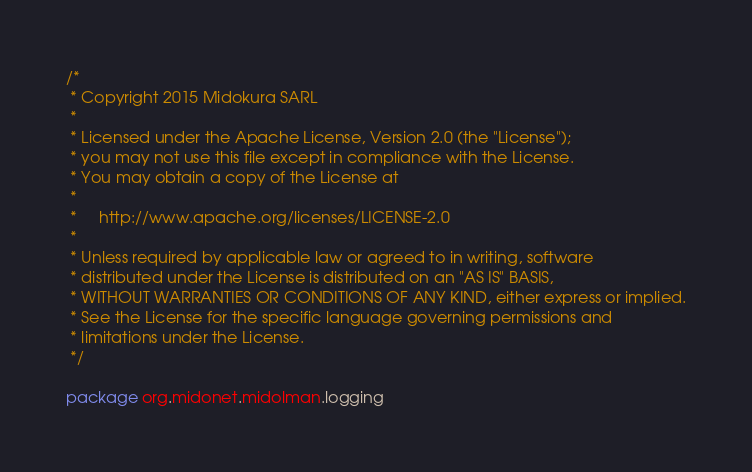<code> <loc_0><loc_0><loc_500><loc_500><_Scala_>/*
 * Copyright 2015 Midokura SARL
 *
 * Licensed under the Apache License, Version 2.0 (the "License");
 * you may not use this file except in compliance with the License.
 * You may obtain a copy of the License at
 *
 *     http://www.apache.org/licenses/LICENSE-2.0
 *
 * Unless required by applicable law or agreed to in writing, software
 * distributed under the License is distributed on an "AS IS" BASIS,
 * WITHOUT WARRANTIES OR CONDITIONS OF ANY KIND, either express or implied.
 * See the License for the specific language governing permissions and
 * limitations under the License.
 */

package org.midonet.midolman.logging
</code> 